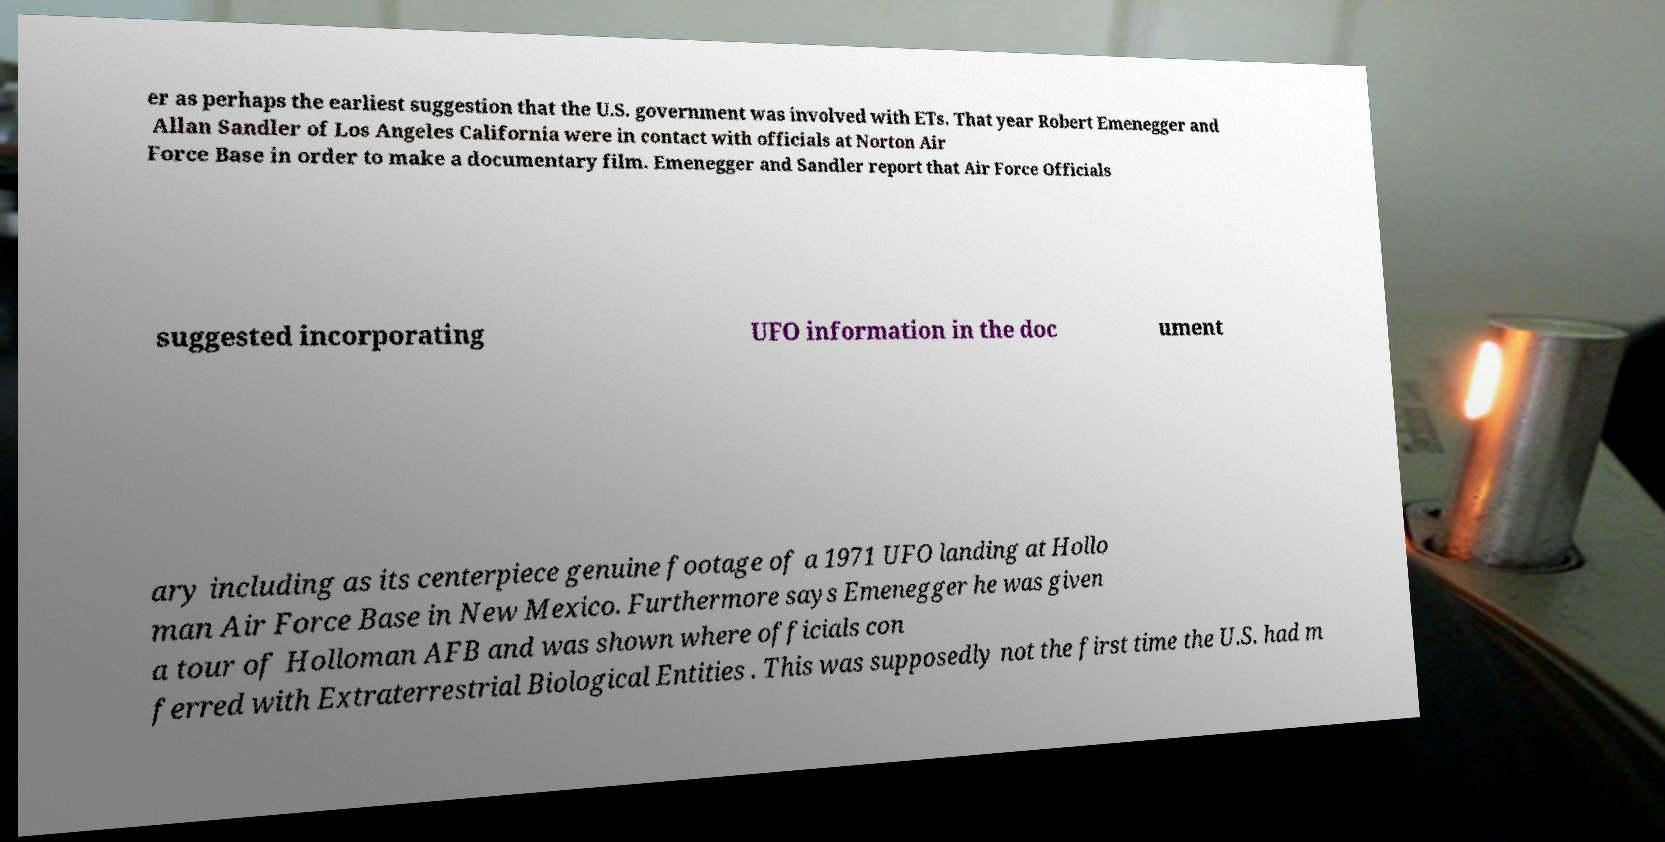Could you assist in decoding the text presented in this image and type it out clearly? er as perhaps the earliest suggestion that the U.S. government was involved with ETs. That year Robert Emenegger and Allan Sandler of Los Angeles California were in contact with officials at Norton Air Force Base in order to make a documentary film. Emenegger and Sandler report that Air Force Officials suggested incorporating UFO information in the doc ument ary including as its centerpiece genuine footage of a 1971 UFO landing at Hollo man Air Force Base in New Mexico. Furthermore says Emenegger he was given a tour of Holloman AFB and was shown where officials con ferred with Extraterrestrial Biological Entities . This was supposedly not the first time the U.S. had m 